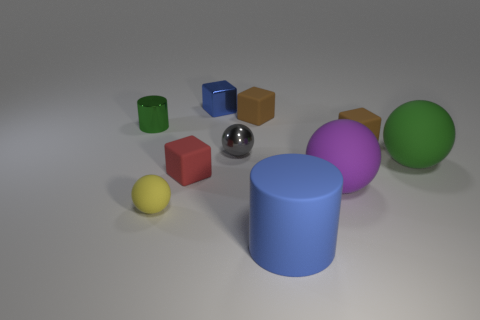There is a thing that is both behind the gray ball and to the right of the big blue rubber thing; what color is it?
Give a very brief answer. Brown. There is a matte object behind the metallic thing that is left of the red cube; what size is it?
Give a very brief answer. Small. Is there a small cube of the same color as the small cylinder?
Provide a short and direct response. No. Are there the same number of blue metal objects right of the large purple rubber ball and tiny blue metal objects?
Keep it short and to the point. No. How many small brown rubber blocks are there?
Give a very brief answer. 2. The large rubber thing that is both to the left of the green matte thing and right of the large cylinder has what shape?
Ensure brevity in your answer.  Sphere. There is a tiny ball that is to the right of the small shiny cube; is its color the same as the small rubber cube to the left of the small gray metal ball?
Your response must be concise. No. There is a block that is the same color as the large rubber cylinder; what is its size?
Your response must be concise. Small. Are there any large things that have the same material as the large green ball?
Your answer should be very brief. Yes. Are there an equal number of small brown rubber things that are behind the blue cube and big purple objects that are right of the green cylinder?
Give a very brief answer. No. 